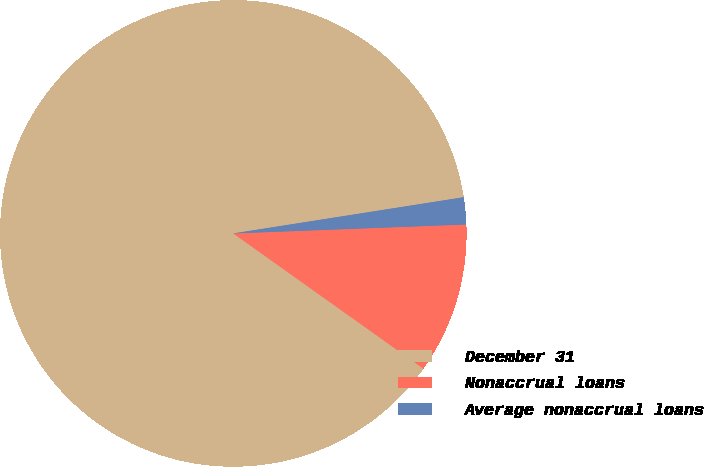Convert chart. <chart><loc_0><loc_0><loc_500><loc_500><pie_chart><fcel>December 31<fcel>Nonaccrual loans<fcel>Average nonaccrual loans<nl><fcel>87.67%<fcel>10.45%<fcel>1.87%<nl></chart> 